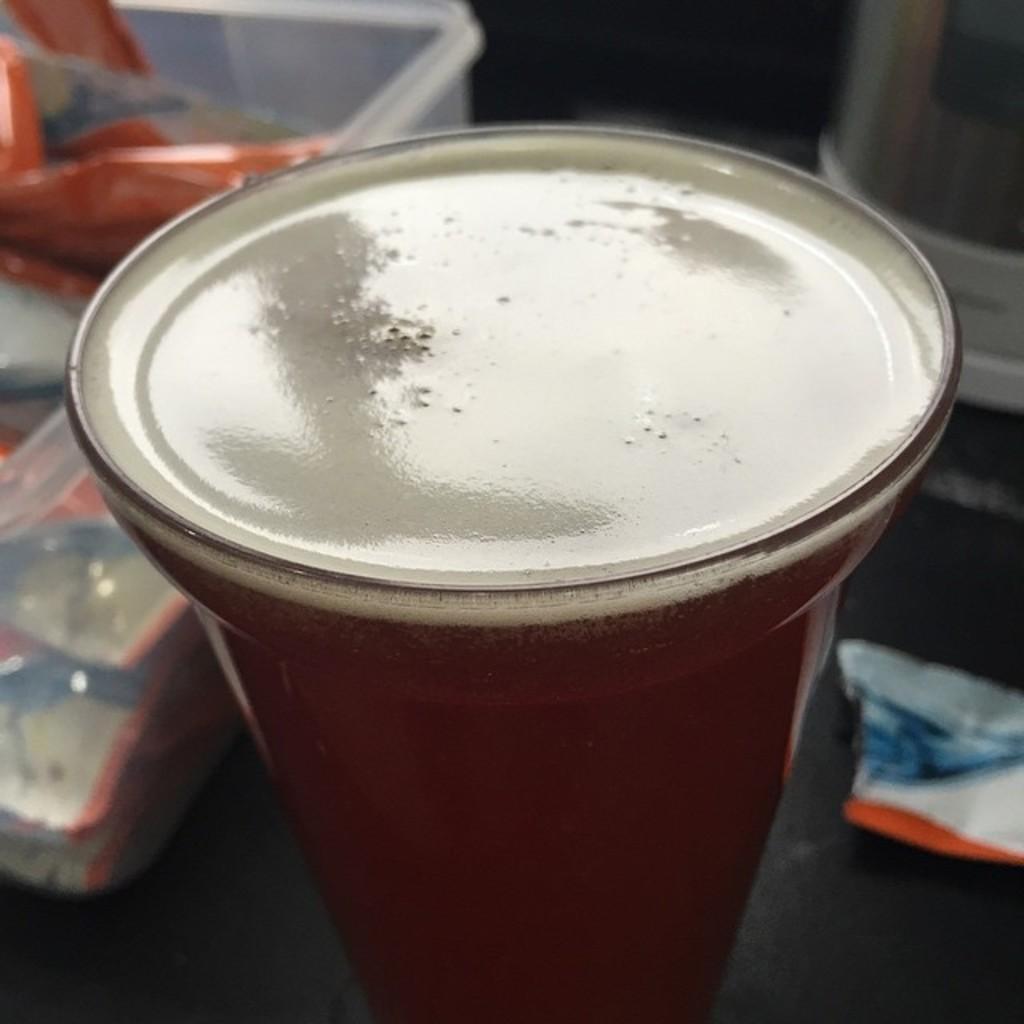Please provide a concise description of this image. In this image I can see the glass. In the glass I can see the liquid. Background I can see the box. 